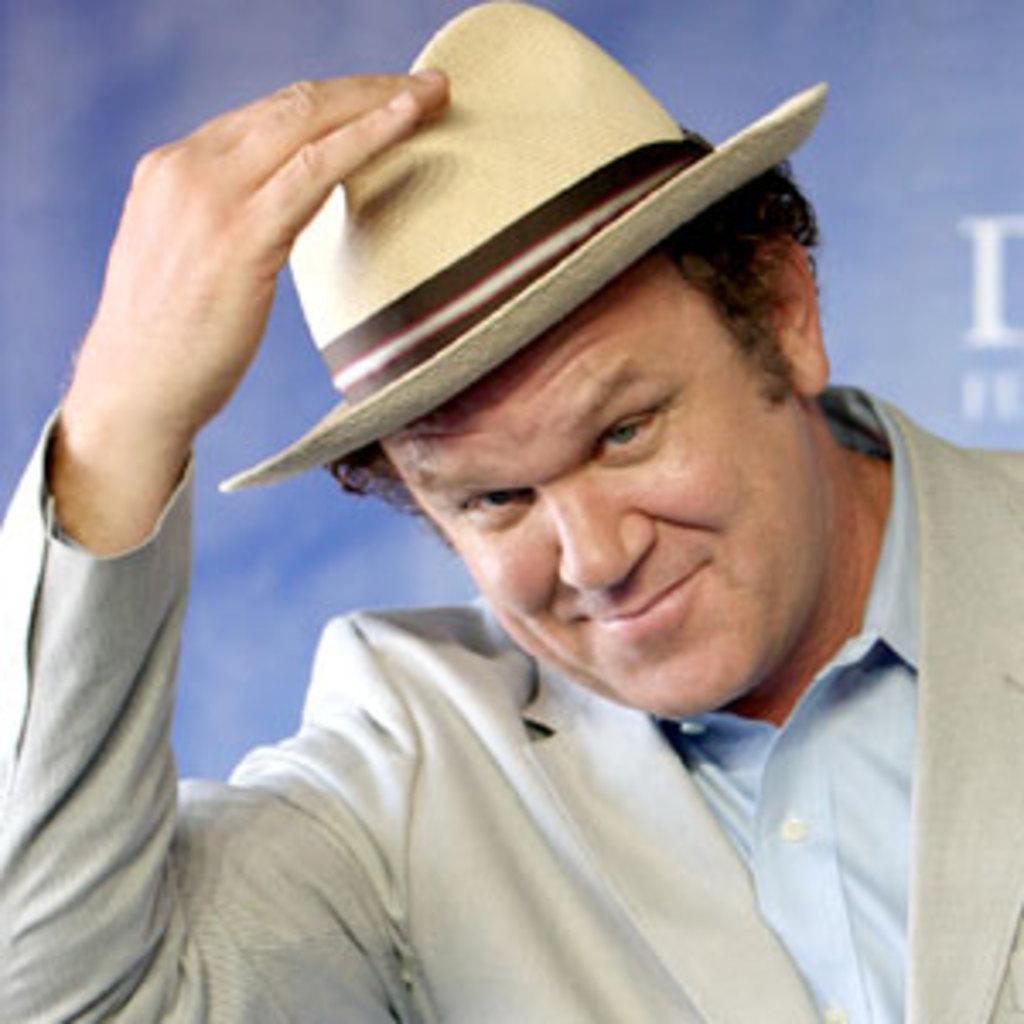Can you describe this image briefly? In this image I can see a man in the front and I can also see smile on his face. I can see he is wearing a grey colour blazer, a blue colour shirt and a hat. In the background I can see a blue colour thing and on it I can see something is written on the right side. 